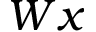<formula> <loc_0><loc_0><loc_500><loc_500>W x</formula> 